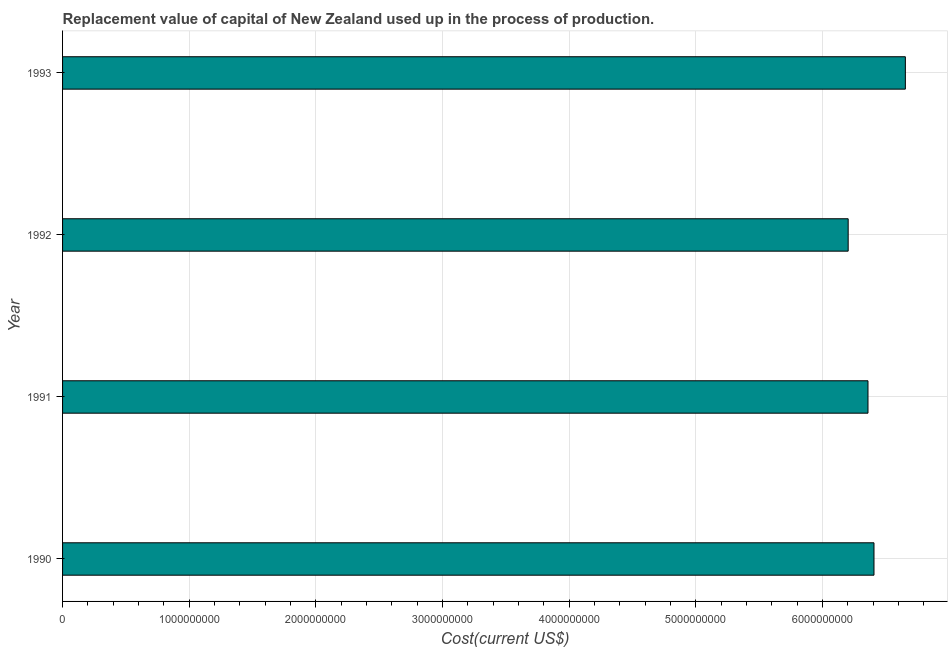Does the graph contain any zero values?
Keep it short and to the point. No. Does the graph contain grids?
Your answer should be very brief. Yes. What is the title of the graph?
Offer a terse response. Replacement value of capital of New Zealand used up in the process of production. What is the label or title of the X-axis?
Ensure brevity in your answer.  Cost(current US$). What is the label or title of the Y-axis?
Your response must be concise. Year. What is the consumption of fixed capital in 1991?
Make the answer very short. 6.36e+09. Across all years, what is the maximum consumption of fixed capital?
Make the answer very short. 6.65e+09. Across all years, what is the minimum consumption of fixed capital?
Ensure brevity in your answer.  6.20e+09. In which year was the consumption of fixed capital maximum?
Keep it short and to the point. 1993. What is the sum of the consumption of fixed capital?
Keep it short and to the point. 2.56e+1. What is the difference between the consumption of fixed capital in 1990 and 1992?
Provide a short and direct response. 2.04e+08. What is the average consumption of fixed capital per year?
Provide a succinct answer. 6.40e+09. What is the median consumption of fixed capital?
Your answer should be very brief. 6.38e+09. Do a majority of the years between 1991 and 1990 (inclusive) have consumption of fixed capital greater than 5200000000 US$?
Provide a succinct answer. No. What is the difference between the highest and the second highest consumption of fixed capital?
Provide a short and direct response. 2.48e+08. Is the sum of the consumption of fixed capital in 1991 and 1992 greater than the maximum consumption of fixed capital across all years?
Provide a short and direct response. Yes. What is the difference between the highest and the lowest consumption of fixed capital?
Offer a very short reply. 4.51e+08. How many bars are there?
Make the answer very short. 4. What is the difference between two consecutive major ticks on the X-axis?
Ensure brevity in your answer.  1.00e+09. What is the Cost(current US$) in 1990?
Your answer should be very brief. 6.41e+09. What is the Cost(current US$) in 1991?
Offer a terse response. 6.36e+09. What is the Cost(current US$) in 1992?
Your response must be concise. 6.20e+09. What is the Cost(current US$) in 1993?
Make the answer very short. 6.65e+09. What is the difference between the Cost(current US$) in 1990 and 1991?
Offer a terse response. 4.74e+07. What is the difference between the Cost(current US$) in 1990 and 1992?
Offer a terse response. 2.04e+08. What is the difference between the Cost(current US$) in 1990 and 1993?
Provide a succinct answer. -2.48e+08. What is the difference between the Cost(current US$) in 1991 and 1992?
Keep it short and to the point. 1.56e+08. What is the difference between the Cost(current US$) in 1991 and 1993?
Your response must be concise. -2.95e+08. What is the difference between the Cost(current US$) in 1992 and 1993?
Your answer should be very brief. -4.51e+08. What is the ratio of the Cost(current US$) in 1990 to that in 1991?
Make the answer very short. 1.01. What is the ratio of the Cost(current US$) in 1990 to that in 1992?
Provide a short and direct response. 1.03. What is the ratio of the Cost(current US$) in 1990 to that in 1993?
Ensure brevity in your answer.  0.96. What is the ratio of the Cost(current US$) in 1991 to that in 1992?
Offer a very short reply. 1.02. What is the ratio of the Cost(current US$) in 1991 to that in 1993?
Your answer should be compact. 0.96. What is the ratio of the Cost(current US$) in 1992 to that in 1993?
Your response must be concise. 0.93. 